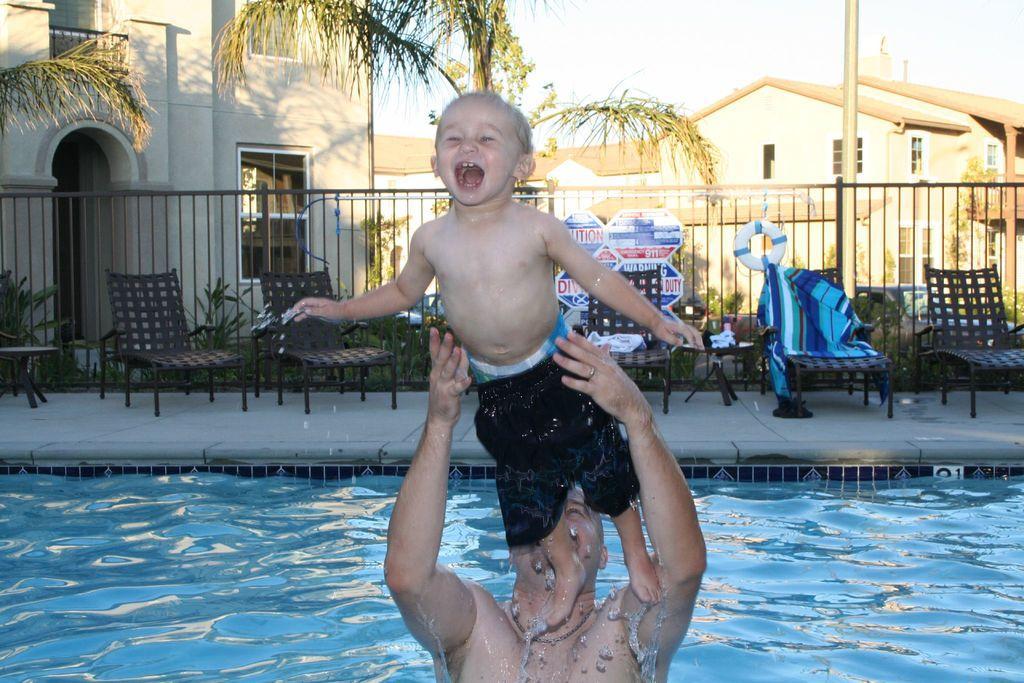How would you summarize this image in a sentence or two? In this picture there is a person standing in the water and holding the boy and the boy is shouting. At the back there are chairs and there is a clothes on the chair. There are plants, trees, buildings and there is a pole behind the railing and there is a poster on the railing. At the top there is sky. At the bottom there is water. 